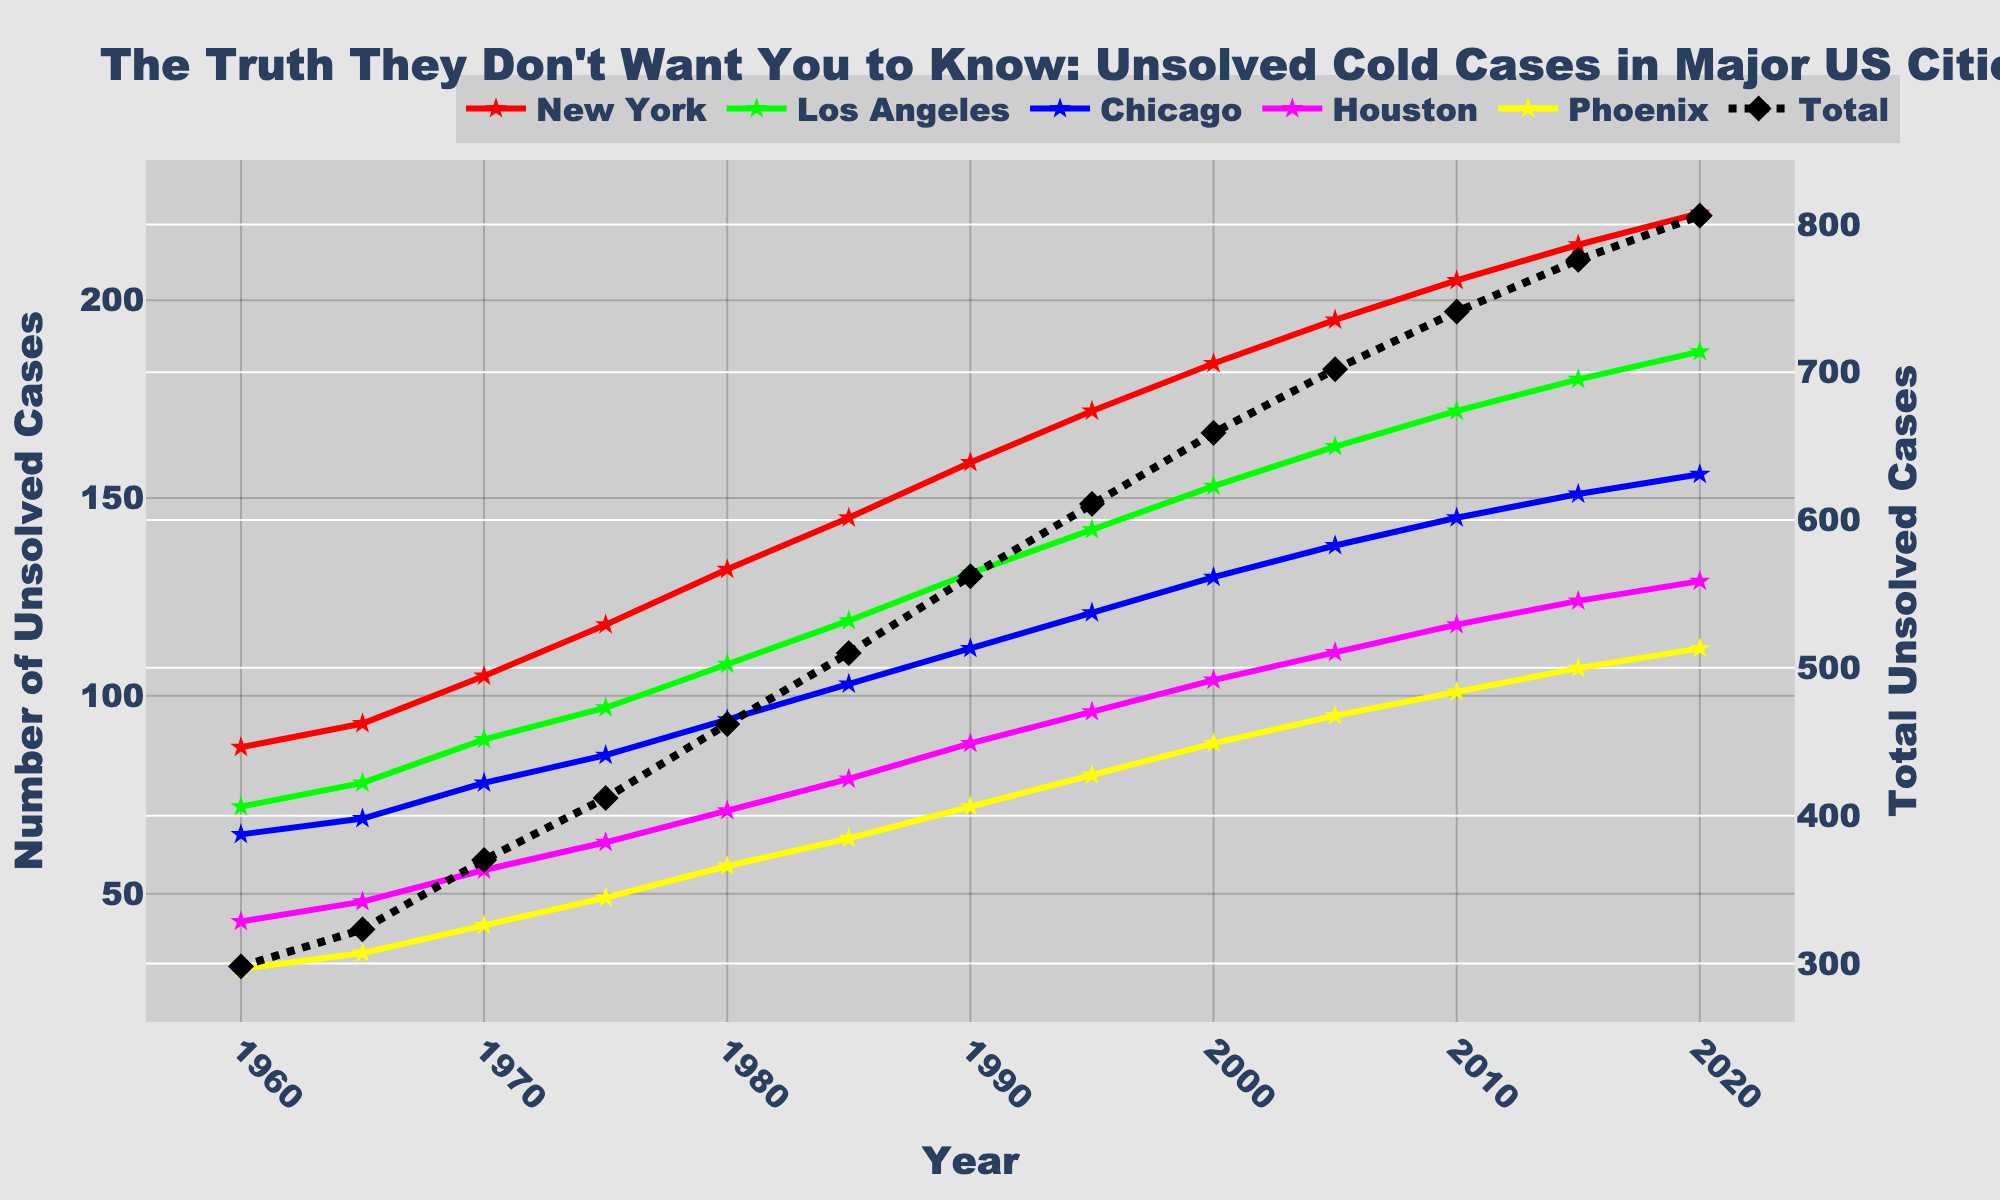Which year had the highest number of unsolved cold cases in New York? Look at the line representing New York; the peak is at 2020. The highest number of unsolved cold cases in New York reaches 222.
Answer: 2020 How many total unsolved cold cases were there in the year 2000 across all cities? Sum the unsolved cases of all five cities for the year 2000: 184 + 153 + 130 + 104 + 88 = 659.
Answer: 659 Which city had more unsolved cases in 1985, Chicago or Houston? Compare the values for Chicago and Houston in 1985. Chicago had 103 and Houston had 79. Thus, Chicago had more unsolved cases.
Answer: Chicago What is the difference in the number of unsolved cases between Los Angeles and Phoenix in 2015? Subtract the number of cases in Phoenix from those in Los Angeles for 2015: 180 - 107 = 73.
Answer: 73 During which decade did New York see the greatest increase in unsolved cases? Compare the increase in cases each decade. From the data: 
1960 to 1970: 105 - 87 = 18 
1970 to 1980: 132 - 105 = 27 
1980 to 1990: 159 - 132 = 27 
1990 to 2000: 184 - 159 = 25
The greatest increase is 27, which occurred between 1970 to 1990. Therefore, the 1970-1980 and 1980-1990 decades saw the greatest increase.
Answer: 1970s-1980s and 1980s-1990s In which year did Houston’s unsolved cases reach 111? Check the plot for when Houston's cases hit 111. It is in 2005.
Answer: 2005 Which city showed a continual increase in unsolved cases every recorded year from 1960 to 2020? Check each city's trend. Only New York consistently shows a continual rise in cases each year without any decrease.
Answer: New York In 1990, were the total unsolved cases across all cities more or less than 600? Calculate the total unsolved cases for 1990: 159 + 131 + 112 + 88 + 72 = 562. It's less than 600.
Answer: Less than 600 What color represents Chicago in the plot? Visually checking the plot, Chicago is represented by the blue-colored line.
Answer: Blue Ignoring the total line, which city had the second highest number of cold cases in 2020? From the plot, the highest number is New York, followed by Los Angeles. Los Angeles had 187 cases in 2020.
Answer: Los Angeles 